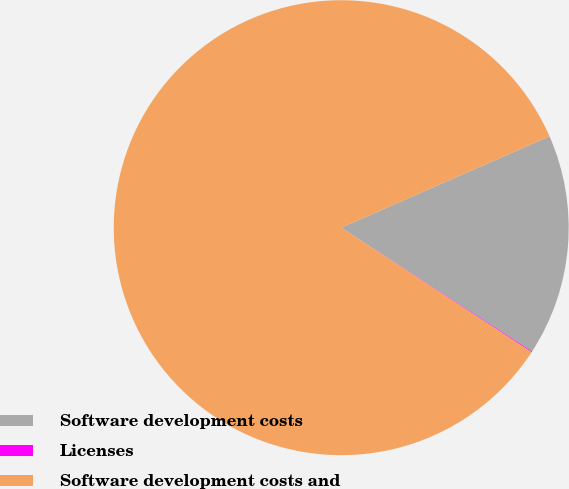Convert chart. <chart><loc_0><loc_0><loc_500><loc_500><pie_chart><fcel>Software development costs<fcel>Licenses<fcel>Software development costs and<nl><fcel>15.74%<fcel>0.06%<fcel>84.2%<nl></chart> 